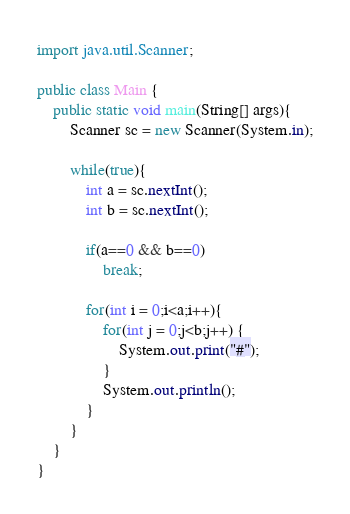<code> <loc_0><loc_0><loc_500><loc_500><_Java_>import java.util.Scanner;

public class Main {
    public static void main(String[] args){
        Scanner sc = new Scanner(System.in);

        while(true){
            int a = sc.nextInt();
            int b = sc.nextInt();

            if(a==0 && b==0)
                break;

            for(int i = 0;i<a;i++){
                for(int j = 0;j<b;j++) {
                    System.out.print("#");
                }
                System.out.println();
            }
        }
    }
}

</code> 